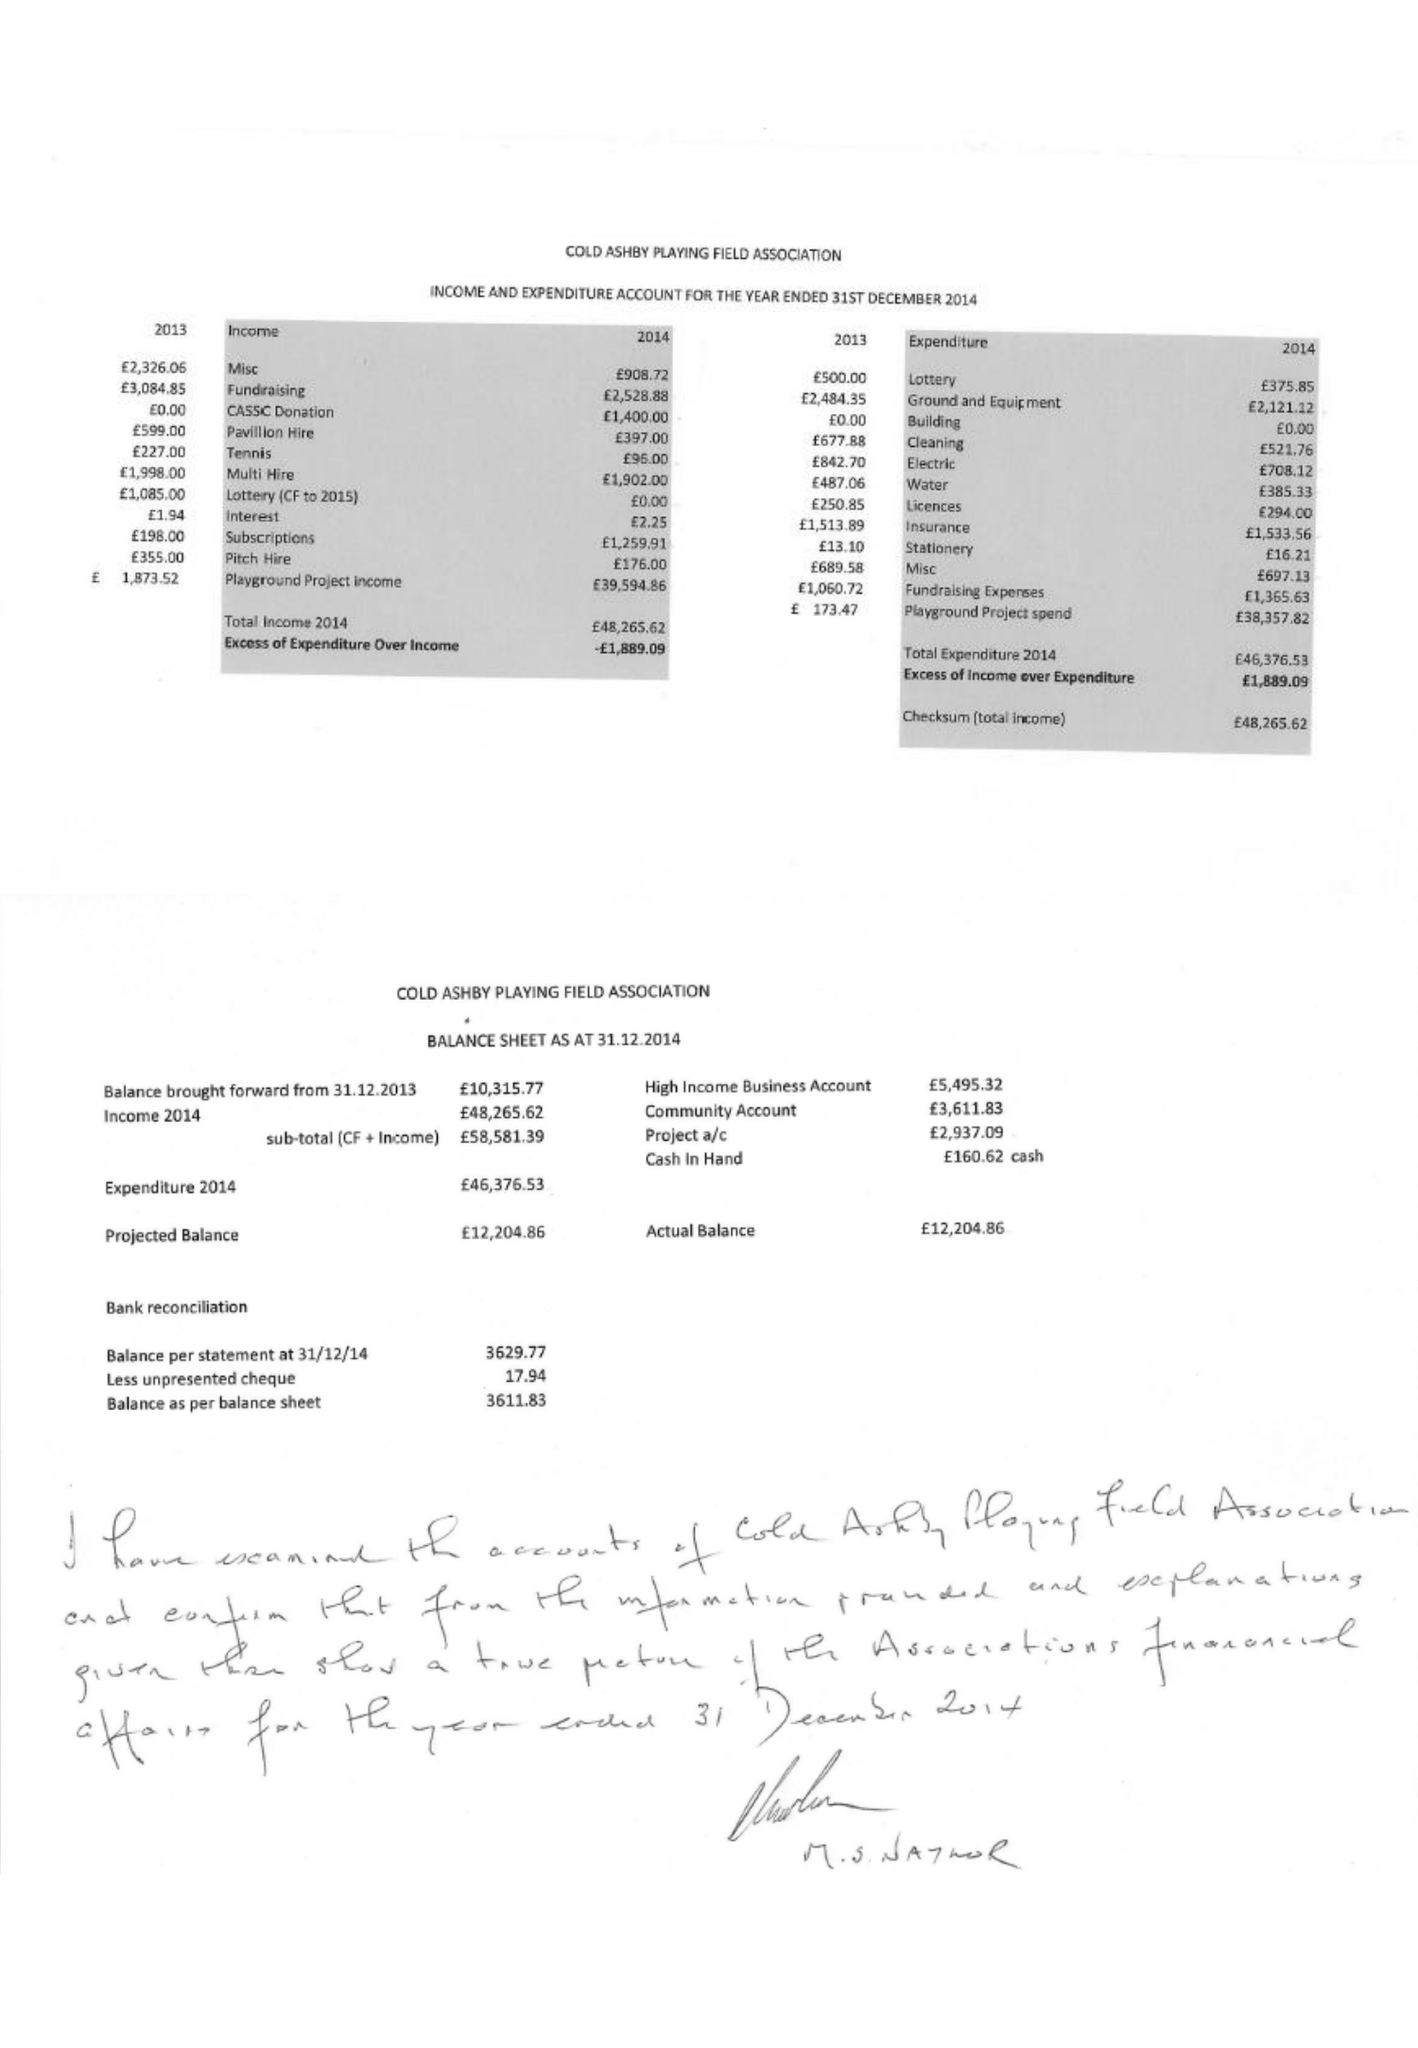What is the value for the charity_number?
Answer the question using a single word or phrase. 282455 